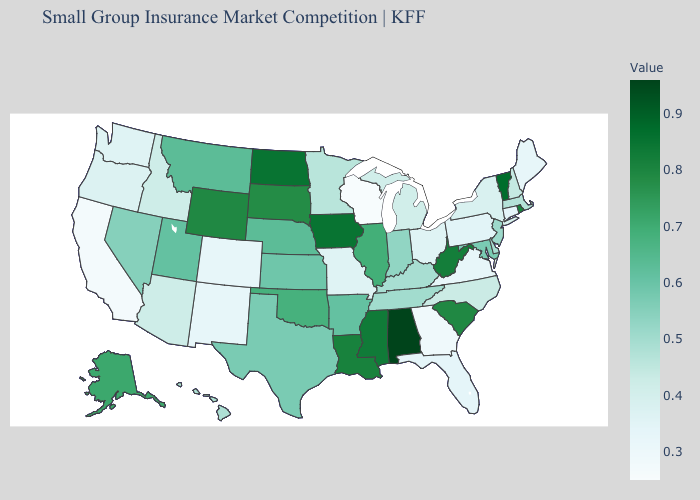Which states have the lowest value in the USA?
Give a very brief answer. Wisconsin. Among the states that border Utah , does Arizona have the lowest value?
Write a very short answer. No. Among the states that border Maine , which have the highest value?
Give a very brief answer. New Hampshire. Does Wyoming have the highest value in the West?
Answer briefly. Yes. Among the states that border North Carolina , which have the lowest value?
Answer briefly. Georgia. Does Delaware have a higher value than Virginia?
Write a very short answer. Yes. 